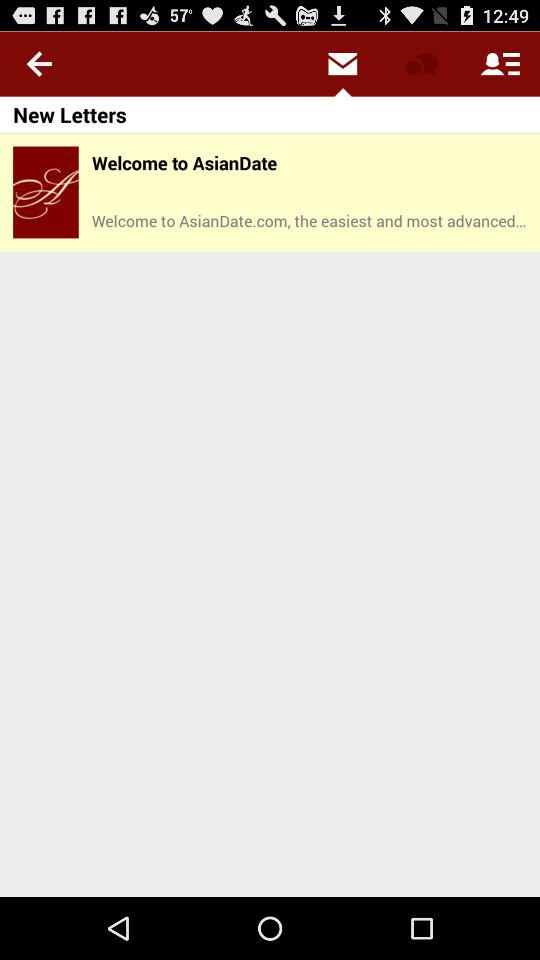What app delivered the letter? The app is "AsianDate". 